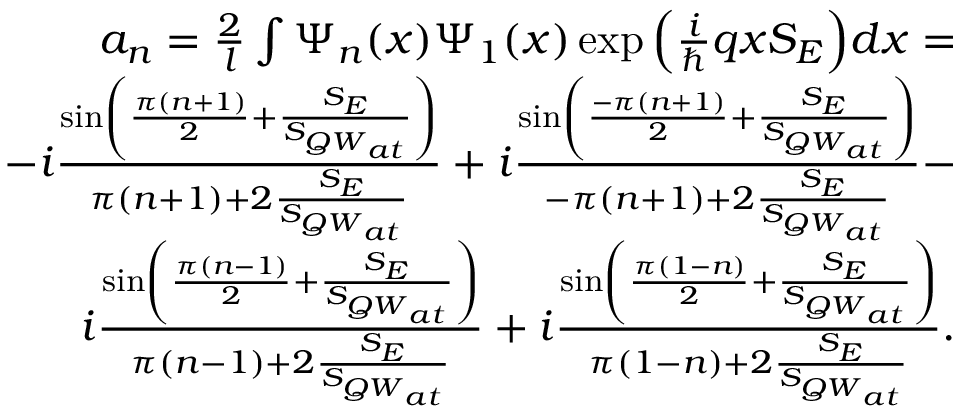Convert formula to latex. <formula><loc_0><loc_0><loc_500><loc_500>\begin{array} { r } { a _ { n } = \frac { 2 } { l } \int \Psi _ { n } ( x ) \Psi _ { 1 } ( x ) \exp { \left ( \frac { i } { } q x S _ { E } \right ) } d x = } \\ { - i \frac { \sin \left ( \frac { \pi ( n + 1 ) } { 2 } + \frac { S _ { E } } { S _ { { Q W } _ { a t } } } \right ) } { \pi ( n + 1 ) + 2 \frac { S _ { E } } { S _ { { Q W } _ { a t } } } } + i \frac { \sin \left ( \frac { - \pi ( n + 1 ) } { 2 } + \frac { S _ { E } } { S _ { { Q W } _ { a t } } } \right ) } { - \pi ( n + 1 ) + 2 \frac { S _ { E } } { S _ { { Q W } _ { a t } } } } - } \\ { i \frac { \sin \left ( \frac { \pi ( n - 1 ) } { 2 } + \frac { S _ { E } } { S _ { { Q W } _ { a t } } } \right ) } { \pi ( n - 1 ) + 2 \frac { S _ { E } } { S _ { { Q W } _ { a t } } } } + i \frac { \sin \left ( \frac { \pi ( 1 - n ) } { 2 } + \frac { S _ { E } } { S _ { { Q W } _ { a t } } } \right ) } { \pi ( 1 - n ) + 2 \frac { S _ { E } } { S _ { { Q W } _ { a t } } } } . } \end{array}</formula> 